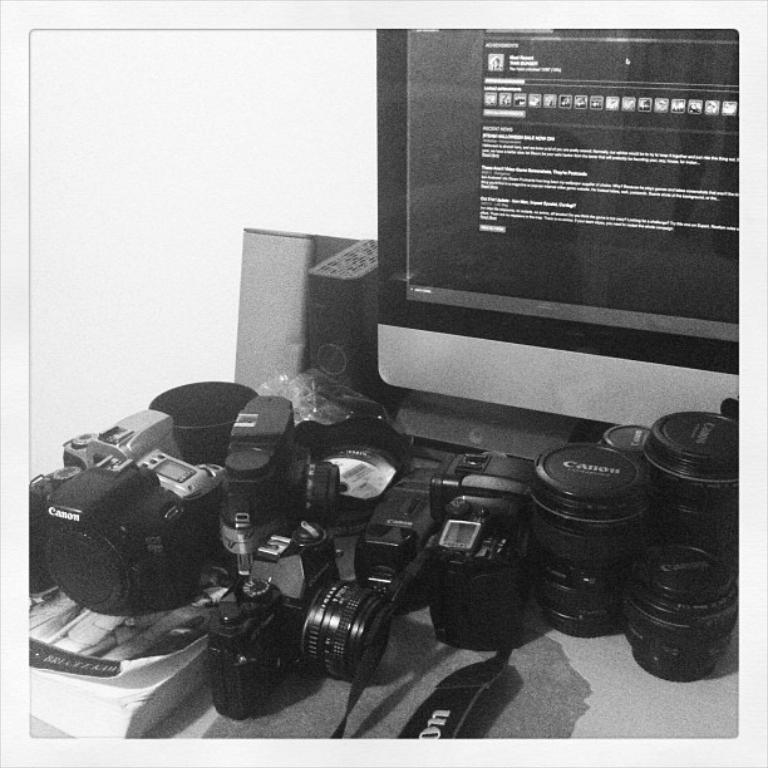What type of electronic devices are in the image? There are cameras and a computer in the image. What part of the computer is visible in the image? The CPU is visible in the image. What else can be seen on the table in the image? There are other objects on the table in the image. Can you tell me how many flames are present in the image? There are no flames present in the image. What company manufactures the computer in the image? The provided facts do not give us any information about the brand or manufacturer of the computer. 